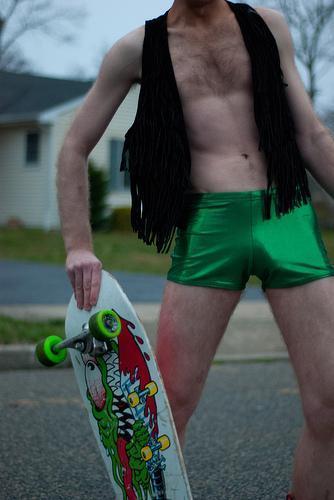How many people are in the picture?
Give a very brief answer. 1. 